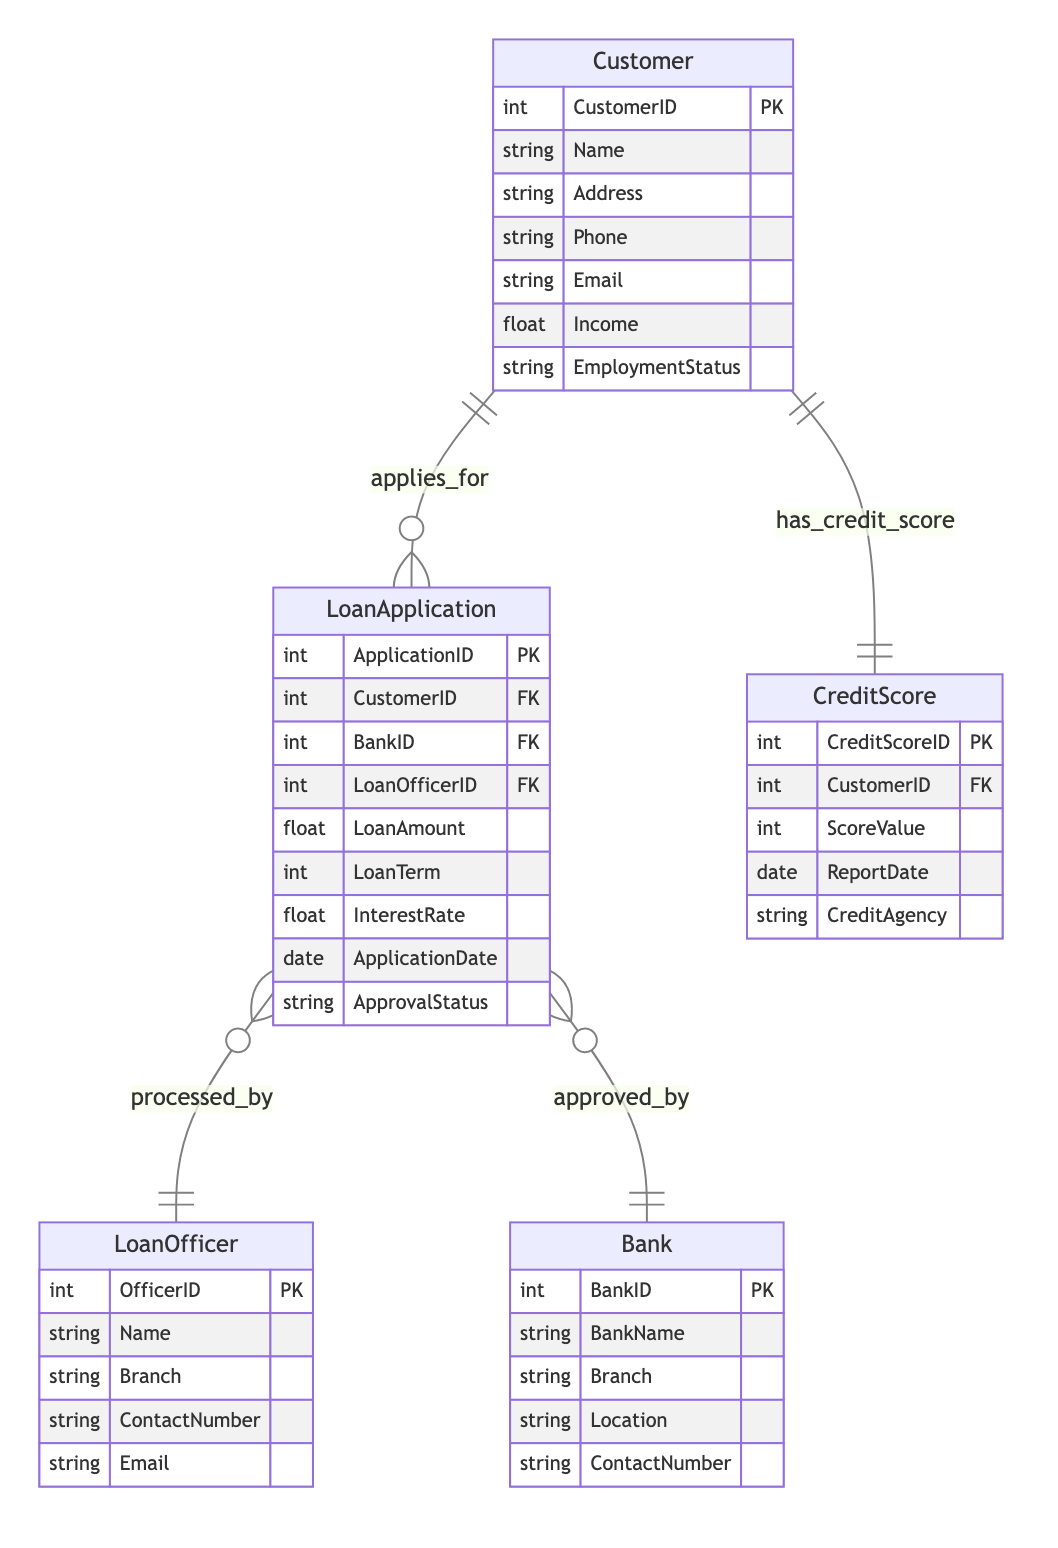What is the primary entity involved in the loan application process? In the diagram, "LoanApplication" is the central element that connects various entities and represents the application process from the customer to the bank.
Answer: LoanApplication How many attributes does the Customer entity have? By examining the "Customer" entity in the diagram, we see it has seven attributes listed: CustomerID, Name, Address, Phone, Email, Income, and EmploymentStatus.
Answer: 7 Which entities are involved in the "applies_for" relationship? The "applies_for" relationship connects the "Customer" entity to the "LoanApplication" entity, indicating that customers apply for loan applications.
Answer: Customer, LoanApplication What is the ApprovalStatus attribute in LoanApplication used for? The "ApprovalStatus" attribute in the "LoanApplication" entity indicates whether the loan application has been approved or denied. It's essential to assess the result of the application process.
Answer: ApprovalStatus Which entity contains the ScoreValue attribute? By looking at the "CreditScore" entity, it is clear that "ScoreValue" is one of its attributes that quantifies the customer's credit history.
Answer: CreditScore How is a LoanApplication processed? The "processed_by" relationship indicates that a "LoanApplication" is handled by a "LoanOfficer," showing that loan officers are responsible for managing the loan application.
Answer: LoanOfficer What is the main purpose of the CreditScore entity? The "CreditScore" entity tracks a customer's creditworthiness over time, as indicated by the attributes related to credit scores and reporting dates for financial assessment.
Answer: Assess creditworthiness Which entity's ApprovalStatus is affected by the Bank? The "LoanApplication" entity's ApprovalStatus is influenced by the "Bank" entity, as indicated by the "approved_by" relationship showing the bank's role in approving loans.
Answer: LoanApplication How does a Customer obtain a CreditScore? The "has_credit_score" relationship specifies that a "Customer" has a "CreditScore," indicating that credit scores are assigned to customers based on their financial history.
Answer: Customer, CreditScore 